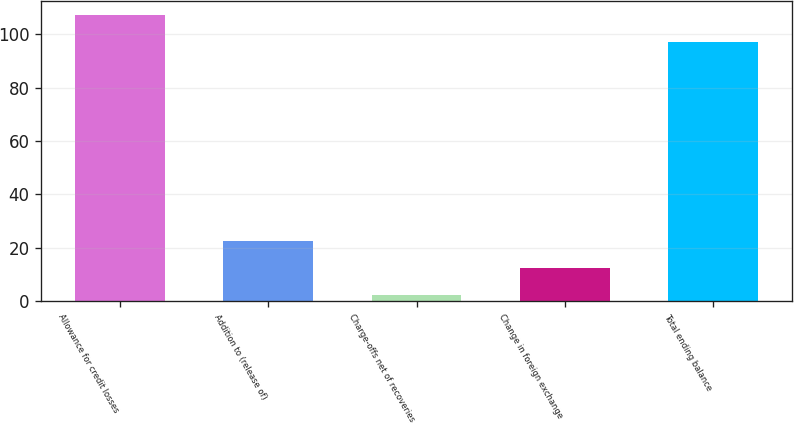Convert chart. <chart><loc_0><loc_0><loc_500><loc_500><bar_chart><fcel>Allowance for credit losses<fcel>Addition to (release of)<fcel>Charge-offs net of recoveries<fcel>Change in foreign exchange<fcel>Total ending balance<nl><fcel>107.17<fcel>22.65<fcel>2.31<fcel>12.48<fcel>97<nl></chart> 